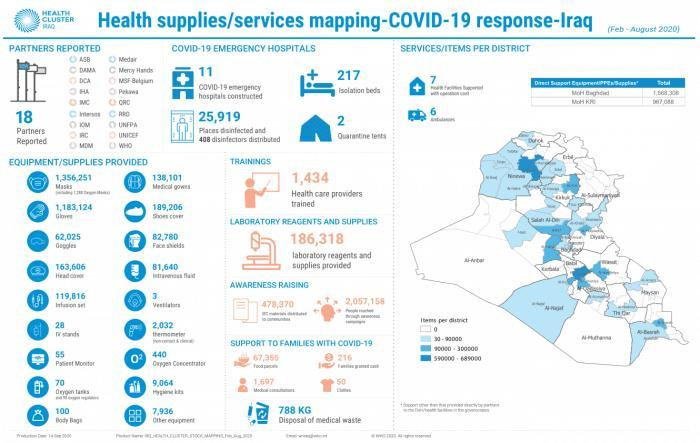What is the total count of TV stands and Body Bags provided
Answer the question with a short phrase. 128 How many quarantine tents 2 how many ventilators and patient monitors were provided 58 How may health care trainers have been trained 1,434 how many food parcels have been provided 67,355 How many ventilators were provided 3 